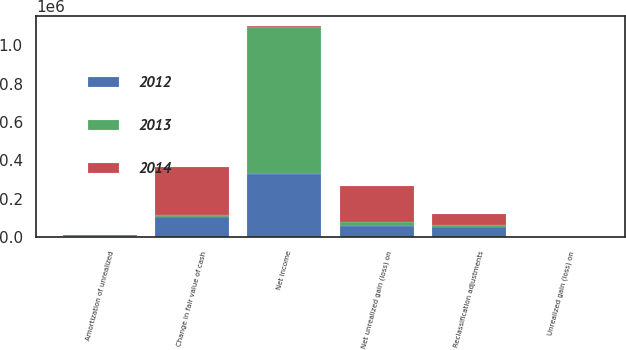Convert chart. <chart><loc_0><loc_0><loc_500><loc_500><stacked_bar_chart><ecel><fcel>Net income<fcel>Unrealized gain (loss) on<fcel>Reclassification adjustments<fcel>Net unrealized gain (loss) on<fcel>Change in fair value of cash<fcel>Amortization of unrealized<nl><fcel>2012<fcel>326328<fcel>153<fcel>50682<fcel>55812<fcel>105414<fcel>1080<nl><fcel>2013<fcel>767823<fcel>73<fcel>14318<fcel>20183<fcel>7614<fcel>1749<nl><fcel>2014<fcel>5095<fcel>149<fcel>56683<fcel>191039<fcel>252817<fcel>5095<nl></chart> 